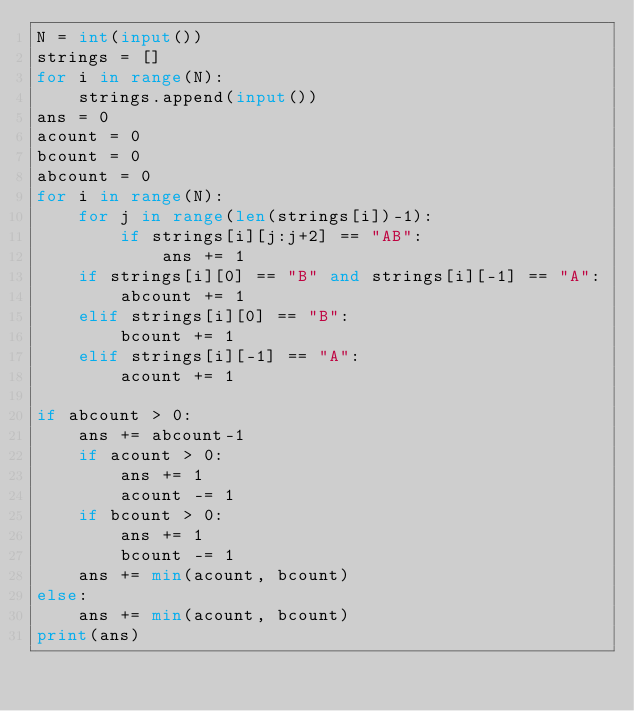Convert code to text. <code><loc_0><loc_0><loc_500><loc_500><_Python_>N = int(input())
strings = []
for i in range(N):
    strings.append(input())
ans = 0
acount = 0
bcount = 0
abcount = 0
for i in range(N):
    for j in range(len(strings[i])-1):
        if strings[i][j:j+2] == "AB":
            ans += 1
    if strings[i][0] == "B" and strings[i][-1] == "A":
        abcount += 1
    elif strings[i][0] == "B":
        bcount += 1
    elif strings[i][-1] == "A":
        acount += 1

if abcount > 0:
    ans += abcount-1
    if acount > 0:
        ans += 1
        acount -= 1
    if bcount > 0:
        ans += 1
        bcount -= 1
    ans += min(acount, bcount)
else:
    ans += min(acount, bcount)
print(ans)
</code> 